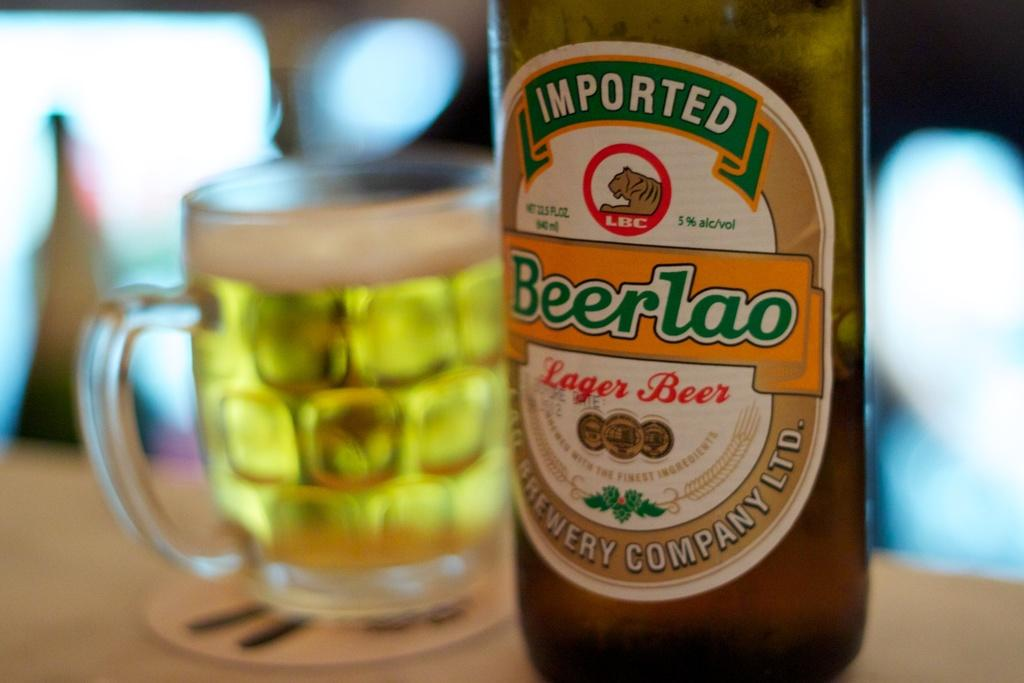What type of container is present in the image? There is a bottle in the image. Can you describe the appearance of the bottle? The bottle resembles a beer bottle. What other container is visible in the image? There is a mug in the image. What is inside the mug? A drink is filled in the mug. Where are the bottle and mug located? Both the bottle and mug are placed on a table. What type of behavior can be observed in the image? There is no behavior depicted in the image; it only shows a bottle, a mug, and their contents. Are there any sticks visible in the image? There are no sticks present in the image. 